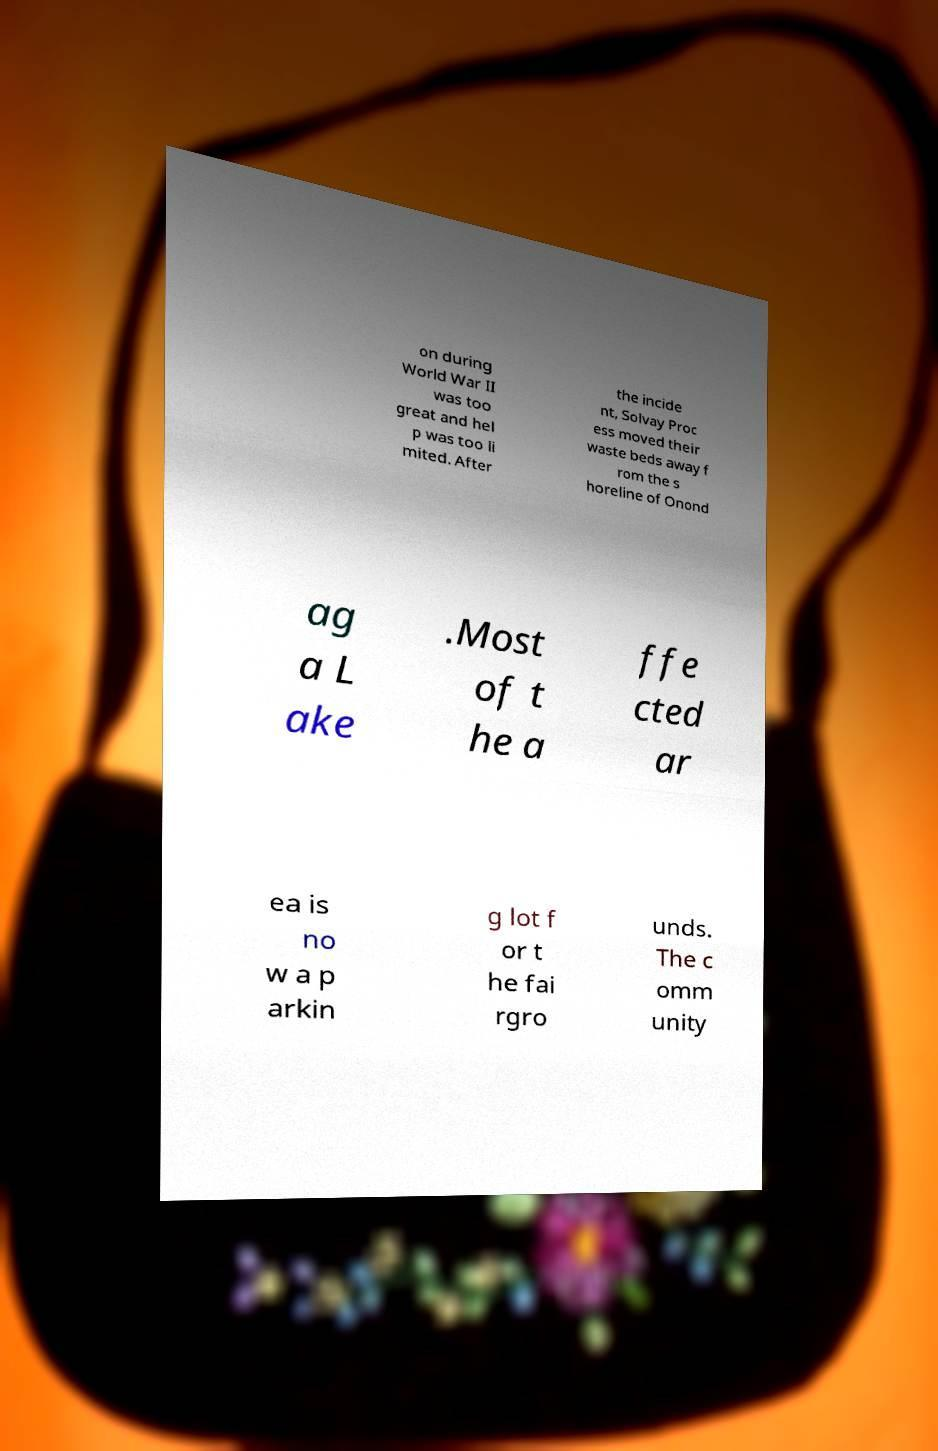For documentation purposes, I need the text within this image transcribed. Could you provide that? on during World War II was too great and hel p was too li mited. After the incide nt, Solvay Proc ess moved their waste beds away f rom the s horeline of Onond ag a L ake .Most of t he a ffe cted ar ea is no w a p arkin g lot f or t he fai rgro unds. The c omm unity 